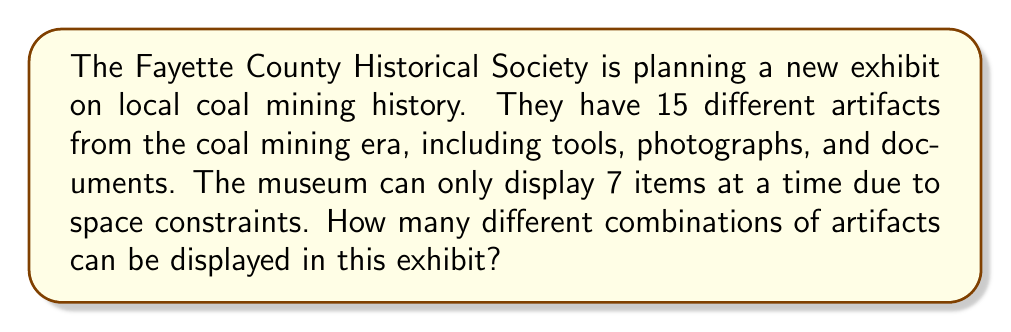Solve this math problem. To solve this problem, we need to use the combination formula. We are selecting 7 items out of 15, where the order doesn't matter (it's not important which item is placed where, just which items are selected).

The formula for combinations is:

$${n \choose k} = \frac{n!}{k!(n-k)!}$$

Where:
$n$ is the total number of items to choose from
$k$ is the number of items being chosen

In this case:
$n = 15$ (total artifacts)
$k = 7$ (artifacts to be displayed)

Let's substitute these values into the formula:

$${15 \choose 7} = \frac{15!}{7!(15-7)!} = \frac{15!}{7!(8)!}$$

Now, let's calculate this step-by-step:

1) $15! = 1,307,674,368,000$
2) $7! = 5,040$
3) $8! = 40,320$

Substituting these values:

$$\frac{1,307,674,368,000}{5,040 \times 40,320}$$

4) $5,040 \times 40,320 = 203,212,800$

5) $\frac{1,307,674,368,000}{203,212,800} = 6,435$

Therefore, there are 6,435 different possible combinations of artifacts that can be displayed in the exhibit.
Answer: 6,435 